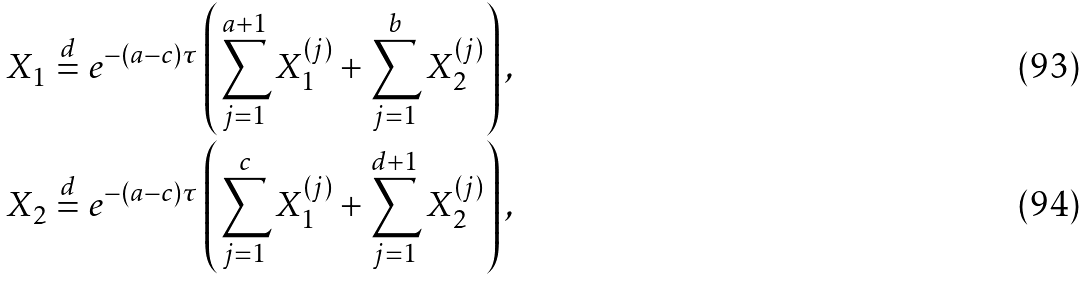Convert formula to latex. <formula><loc_0><loc_0><loc_500><loc_500>X _ { 1 } & \stackrel { d } { = } e ^ { - ( a - c ) \tau } \left ( \sum _ { j = 1 } ^ { a + 1 } X _ { 1 } ^ { ( j ) } + \sum _ { j = 1 } ^ { b } X _ { 2 } ^ { ( j ) } \right ) , \\ X _ { 2 } & \stackrel { d } { = } e ^ { - ( a - c ) \tau } \left ( \sum _ { j = 1 } ^ { c } X _ { 1 } ^ { ( j ) } + \sum _ { j = 1 } ^ { d + 1 } X _ { 2 } ^ { ( j ) } \right ) ,</formula> 